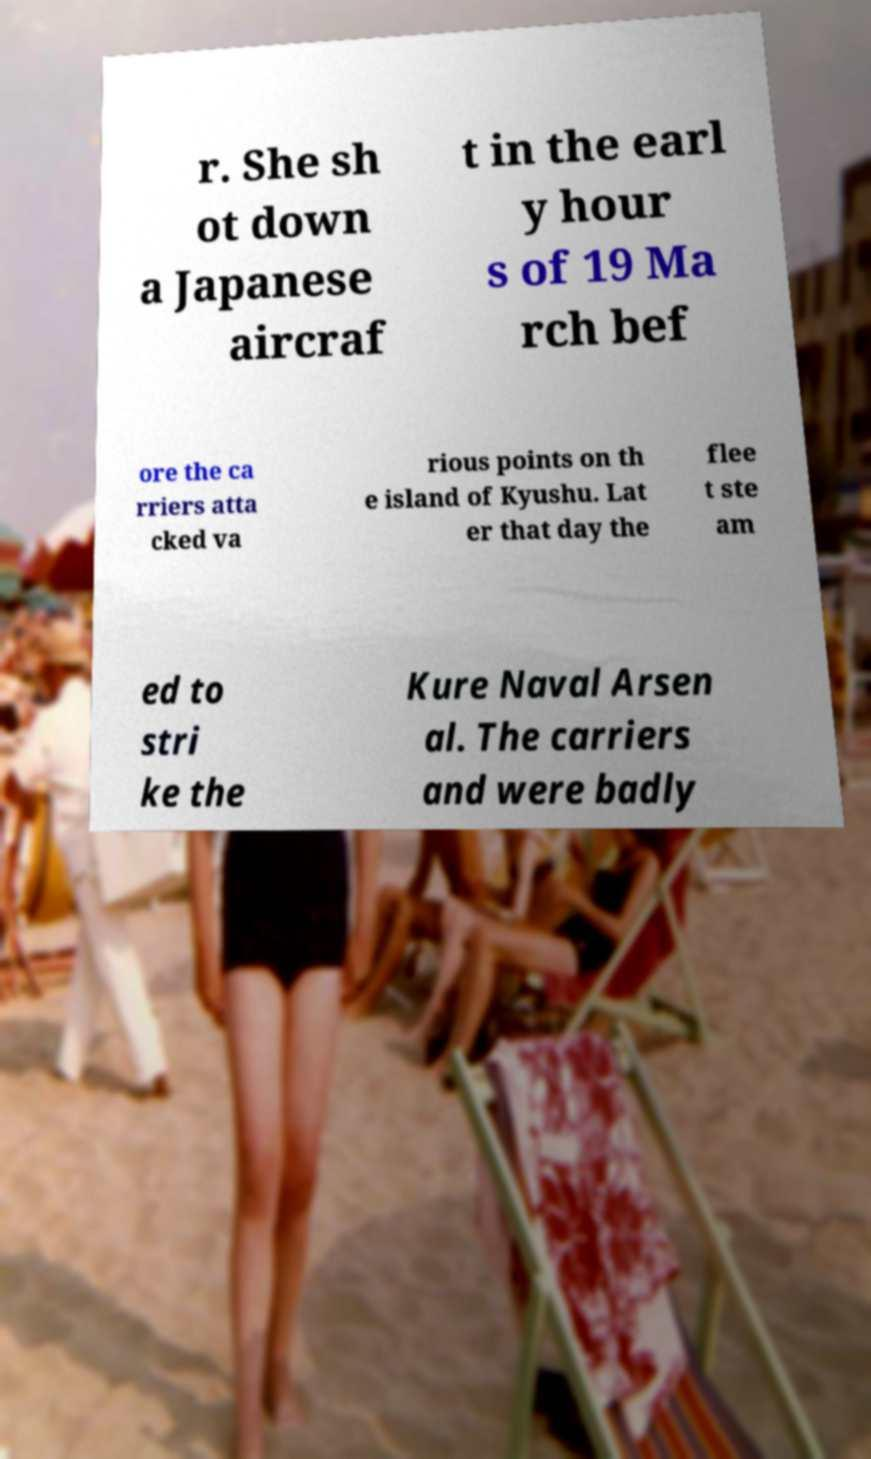There's text embedded in this image that I need extracted. Can you transcribe it verbatim? r. She sh ot down a Japanese aircraf t in the earl y hour s of 19 Ma rch bef ore the ca rriers atta cked va rious points on th e island of Kyushu. Lat er that day the flee t ste am ed to stri ke the Kure Naval Arsen al. The carriers and were badly 